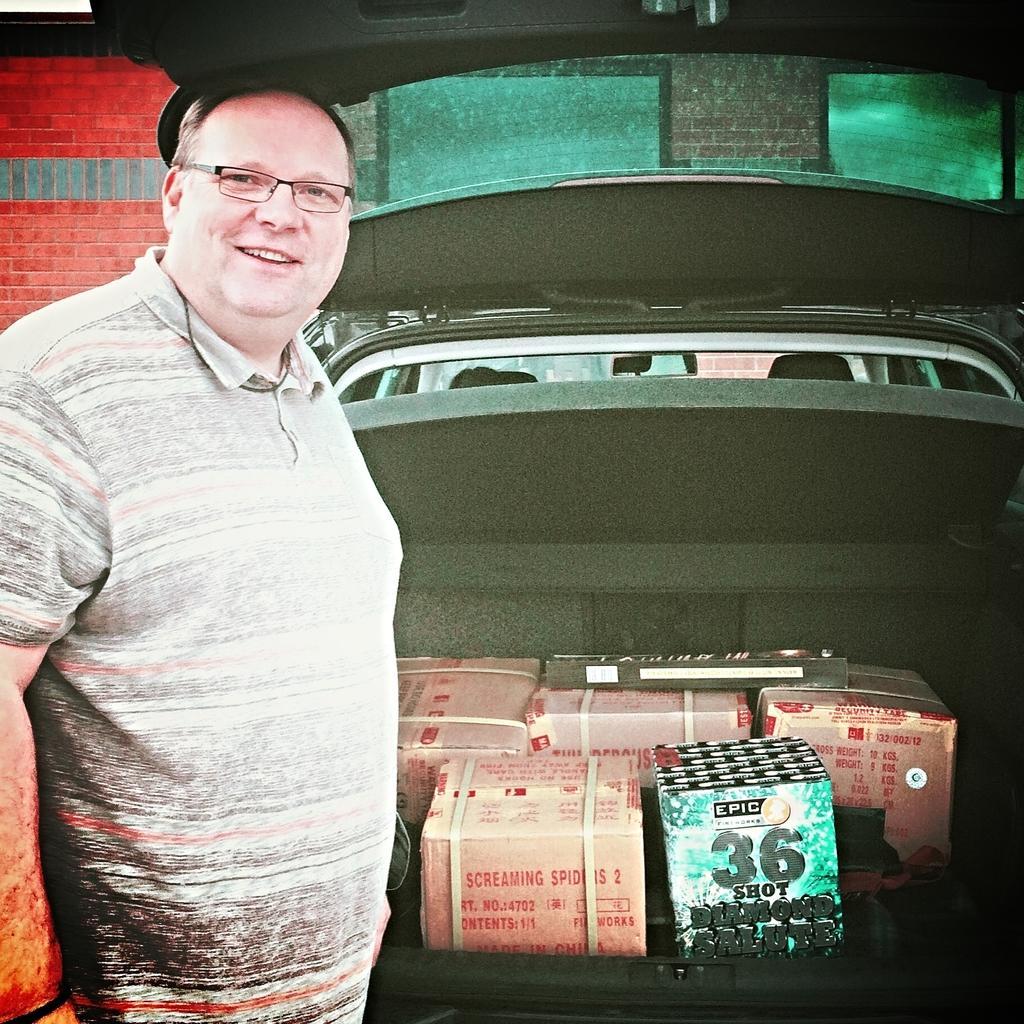Can you describe this image briefly? In this picture we can see a man wore a spectacle and standing and smiling and beside him we can see boxes in a vehicle and in the background we can see the wall. 